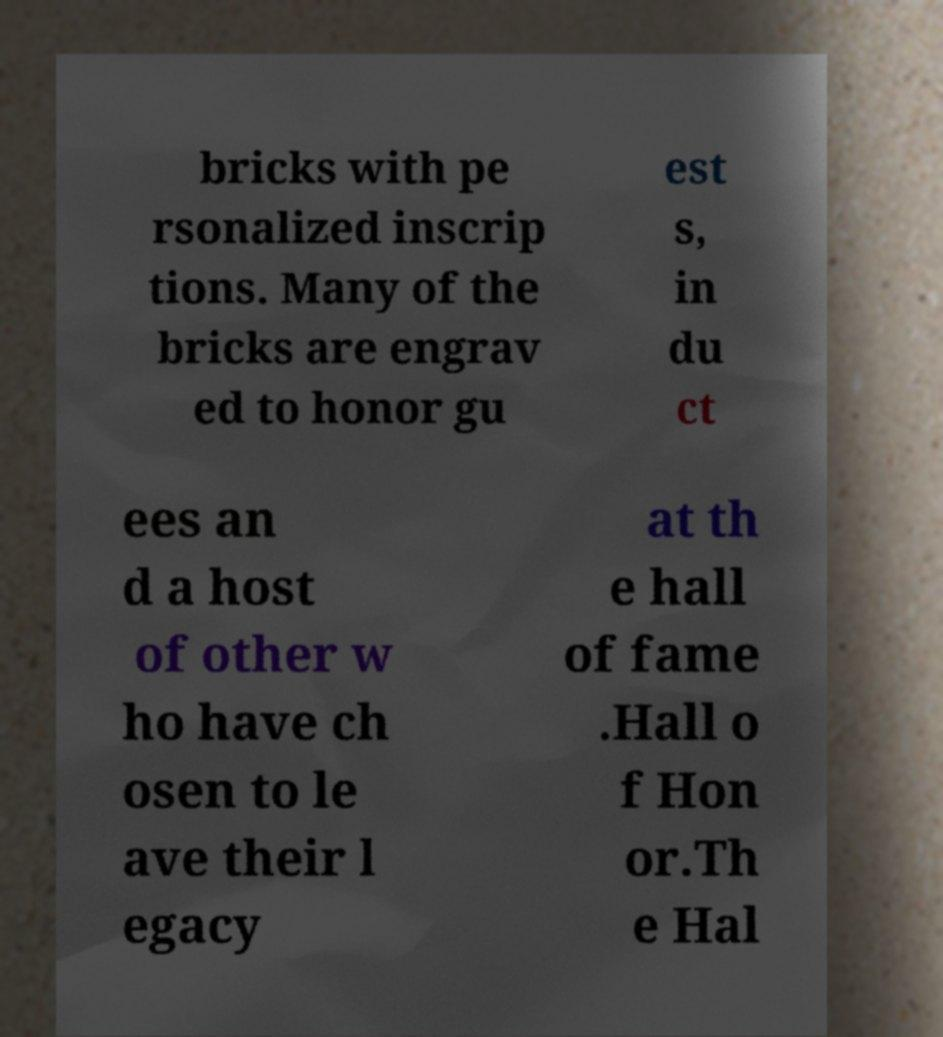Can you read and provide the text displayed in the image?This photo seems to have some interesting text. Can you extract and type it out for me? bricks with pe rsonalized inscrip tions. Many of the bricks are engrav ed to honor gu est s, in du ct ees an d a host of other w ho have ch osen to le ave their l egacy at th e hall of fame .Hall o f Hon or.Th e Hal 